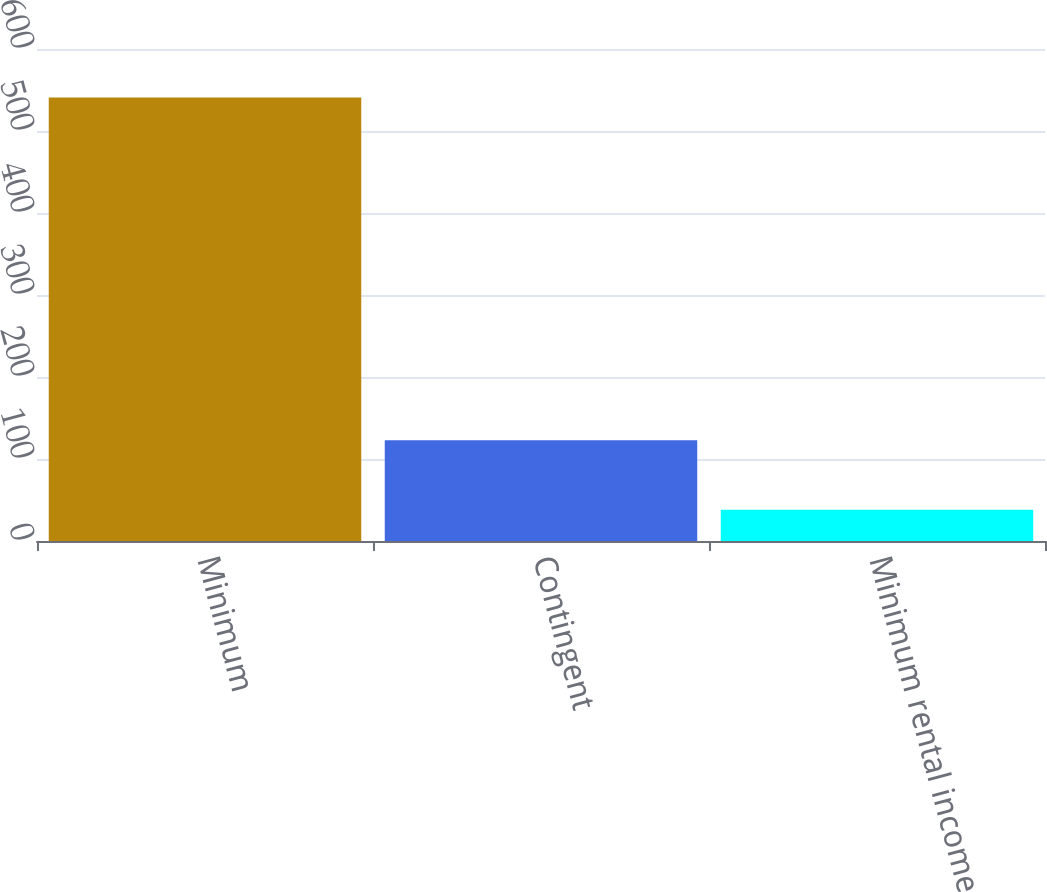<chart> <loc_0><loc_0><loc_500><loc_500><bar_chart><fcel>Minimum<fcel>Contingent<fcel>Minimum rental income<nl><fcel>541<fcel>123<fcel>38<nl></chart> 